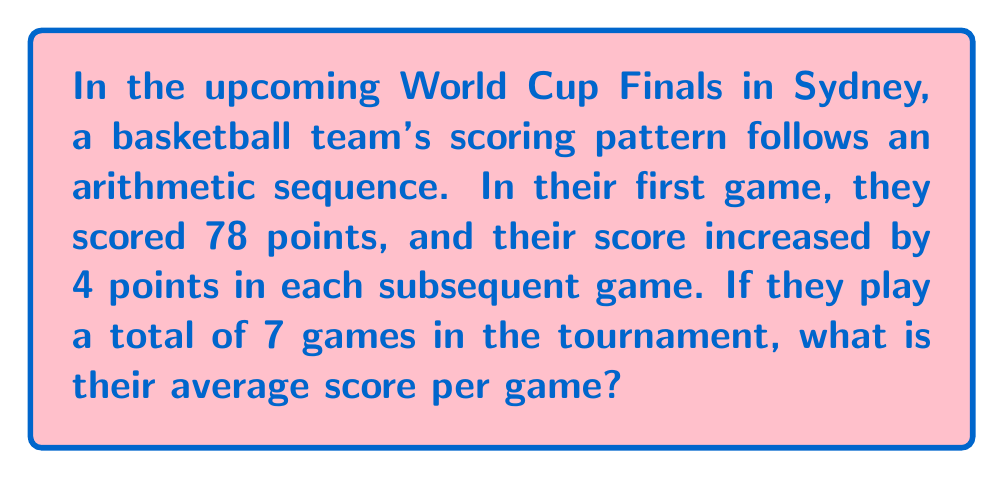What is the answer to this math problem? Let's approach this step-by-step:

1) First, we need to find the arithmetic sequence for the 7 games:
   $a_1 = 78$ (first term)
   $d = 4$ (common difference)
   $n = 7$ (number of terms)

2) The sequence will be: 78, 82, 86, 90, 94, 98, 102

3) To find the average, we need the sum of all scores. We can use the arithmetic sequence sum formula:

   $$S_n = \frac{n}{2}(a_1 + a_n)$$

   Where $a_n$ is the last term, which we can calculate:
   $a_n = a_1 + (n-1)d = 78 + (7-1)4 = 78 + 24 = 102$

4) Now we can calculate the sum:

   $$S_7 = \frac{7}{2}(78 + 102) = \frac{7}{2}(180) = 630$$

5) To get the average, we divide the sum by the number of games:

   $$\text{Average} = \frac{630}{7} = 90$$

Therefore, the team's average score per game is 90 points.
Answer: 90 points 